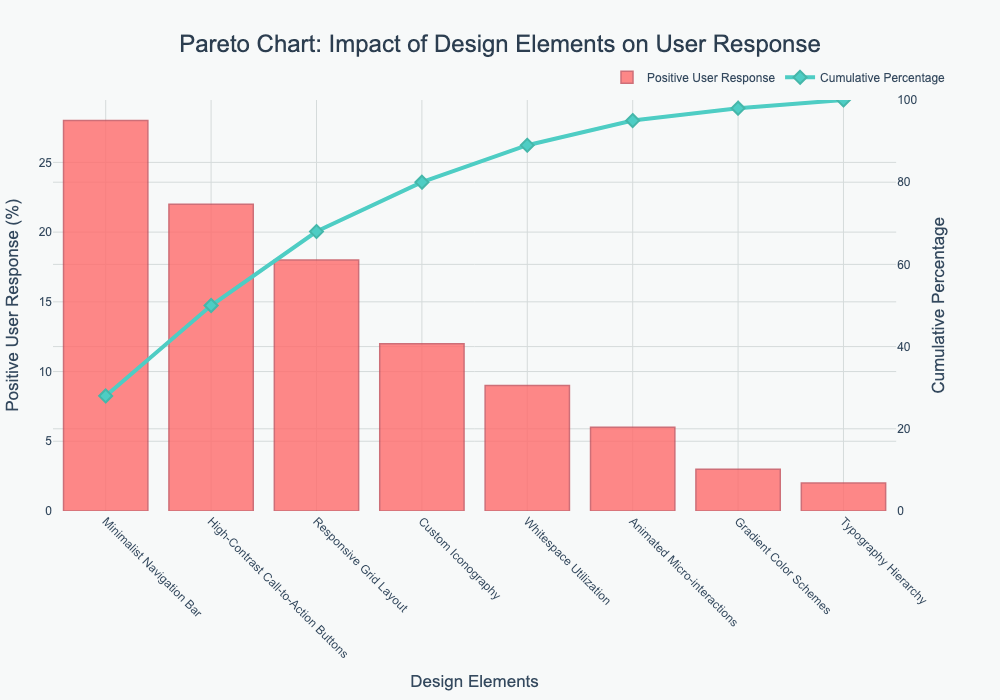What is the most impactful design element according to the Positive User Response percentage? The most impactful design element is the one with the highest percentage in the Positive User Response axis, which is the first element in the Pareto chart. The Minimalist Navigation Bar has the highest Positive User Response at 28%.
Answer: Minimalist Navigation Bar What is the cumulative percentage after including the top three design elements? The cumulative percentage is obtained by summing up the percentages of the top three design elements. According to the chart, the cumulative percentage after the top three elements is 28% + 22% + 18% = 68%.
Answer: 68% Which design element has the lowest Positive User Response? The design element with the lowest Positive User Response is the one with the smallest bar in the Pareto chart. The Typography Hierarchy has the lowest Positive User Response at 2%.
Answer: Typography Hierarchy How does the Cumulative Percentage change between the top two design elements? The change in Cumulative Percentage is calculated by the difference between the cumulative percentage at the second element and the first element. The first element is at 28%, and the second element adds 22%, making it 50%. So, the change is 50% - 28% = 22%.
Answer: 22% What percentage of Positive User Response is attributed to the design elements with at least 10% response? The design elements with at least 10% response are Minimalist Navigation Bar, High-Contrast Call-to-Action Buttons, Responsive Grid Layout, and Custom Iconography. The sum of their contributions is 28% + 22% + 18% + 12% = 80%.
Answer: 80% Which design elements make up more than half of the total Positive User Response when combined? Design elements making up more than half of the total response should cumulatively sum to over 50%. The first element (28%), second element (22%), and third element (18%) add up to 68%, which is more than half.
Answer: Minimalist Navigation Bar, High-Contrast Call-to-Action Buttons, Responsive Grid Layout What is the combined Positive User Response percentage of Custom Iconography and Animated Micro-interactions? Add the Positive User Response percentages of Custom Iconography (12%) and Animated Micro-interactions (6%). The combined percentage is 12% + 6% = 18%.
Answer: 18% If you ignore the bottom two design elements, what would the new cumulative percentage be for the remaining elements? The bottom two elements are Gradient Color Schemes (3%) and Typography Hierarchy (2%), totaling 5%. By removing them from the cumulative total, we have 100% - 5% = 95%.
Answer: 95% Which design element's Positive User Response percentage lies between 10% and 20%? Referring to the chart, the design elements within this range are those whose bars fall between 10% and 20% on the Positive User Response axis. Custom Iconography has a 12% response, which lies between 10% and 20%.
Answer: Custom Iconography 